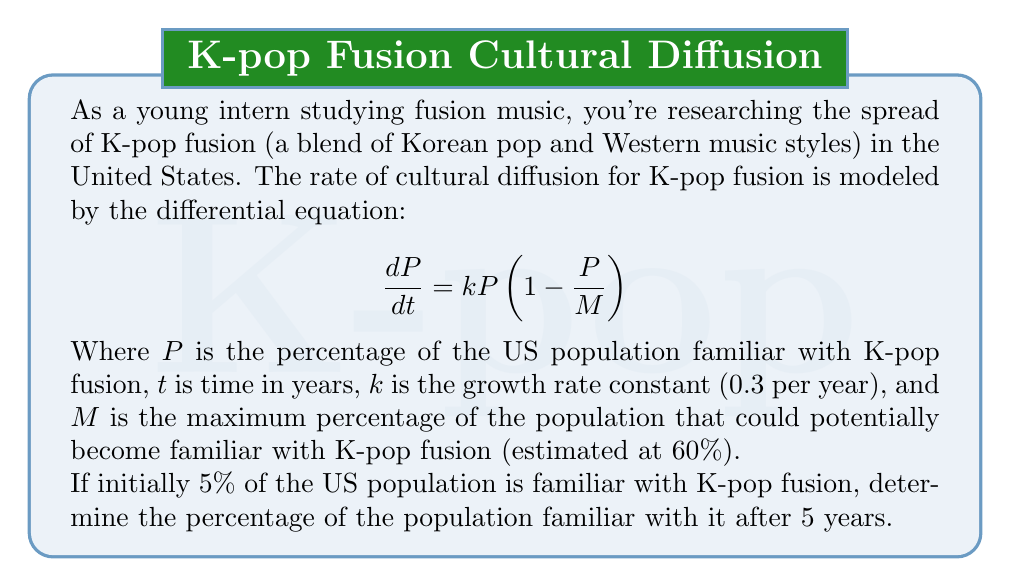Provide a solution to this math problem. To solve this problem, we need to use the logistic growth model, which is a first-order differential equation. Let's approach this step-by-step:

1) The given differential equation is:
   $$\frac{dP}{dt} = kP(1-\frac{P}{M})$$

2) We're given:
   - $k = 0.3$ per year
   - $M = 60\%$
   - Initial condition: $P(0) = 5\%$
   - We need to find $P(5)$

3) The solution to this differential equation is:
   $$P(t) = \frac{MP_0e^{kt}}{M + P_0(e^{kt} - 1)}$$
   Where $P_0$ is the initial value of $P$

4) Let's substitute our known values:
   $$P(t) = \frac{60 \cdot 5e^{0.3t}}{60 + 5(e^{0.3t} - 1)}$$

5) We want to find $P(5)$, so let's substitute $t=5$:
   $$P(5) = \frac{60 \cdot 5e^{0.3 \cdot 5}}{60 + 5(e^{0.3 \cdot 5} - 1)}$$

6) Let's calculate this step-by-step:
   $e^{0.3 \cdot 5} \approx 4.4816$
   
   $$P(5) = \frac{60 \cdot 5 \cdot 4.4816}{60 + 5(4.4816 - 1)}$$
   
   $$= \frac{1344.48}{60 + 17.408}$$
   
   $$= \frac{1344.48}{77.408}$$
   
   $$\approx 17.37\%$$

Therefore, after 5 years, approximately 17.37% of the US population will be familiar with K-pop fusion.
Answer: 17.37% 